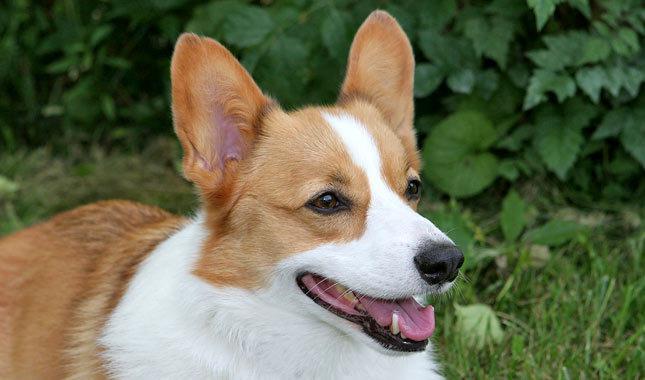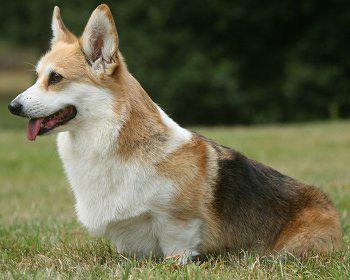The first image is the image on the left, the second image is the image on the right. For the images shown, is this caption "At least one dog is sitting in the grass." true? Answer yes or no. Yes. The first image is the image on the left, the second image is the image on the right. Given the left and right images, does the statement "Two corgies sit side by side in one image, while another corgi with its mouth open and tongue showing is alone in the other image." hold true? Answer yes or no. No. The first image is the image on the left, the second image is the image on the right. Analyze the images presented: Is the assertion "One of the dogs is standing on all four on the grass." valid? Answer yes or no. No. The first image is the image on the left, the second image is the image on the right. Analyze the images presented: Is the assertion "The dog on the right is wearing a collar" valid? Answer yes or no. No. The first image is the image on the left, the second image is the image on the right. Considering the images on both sides, is "One image contains twice as many dogs as the other image." valid? Answer yes or no. No. The first image is the image on the left, the second image is the image on the right. For the images displayed, is the sentence "An image shows two big-eared dog faces slide-by-side." factually correct? Answer yes or no. No. The first image is the image on the left, the second image is the image on the right. Examine the images to the left and right. Is the description "There is a sitting dog in one of the images." accurate? Answer yes or no. Yes. The first image is the image on the left, the second image is the image on the right. Given the left and right images, does the statement "The right image includes twice the number of dogs as the left image." hold true? Answer yes or no. No. 